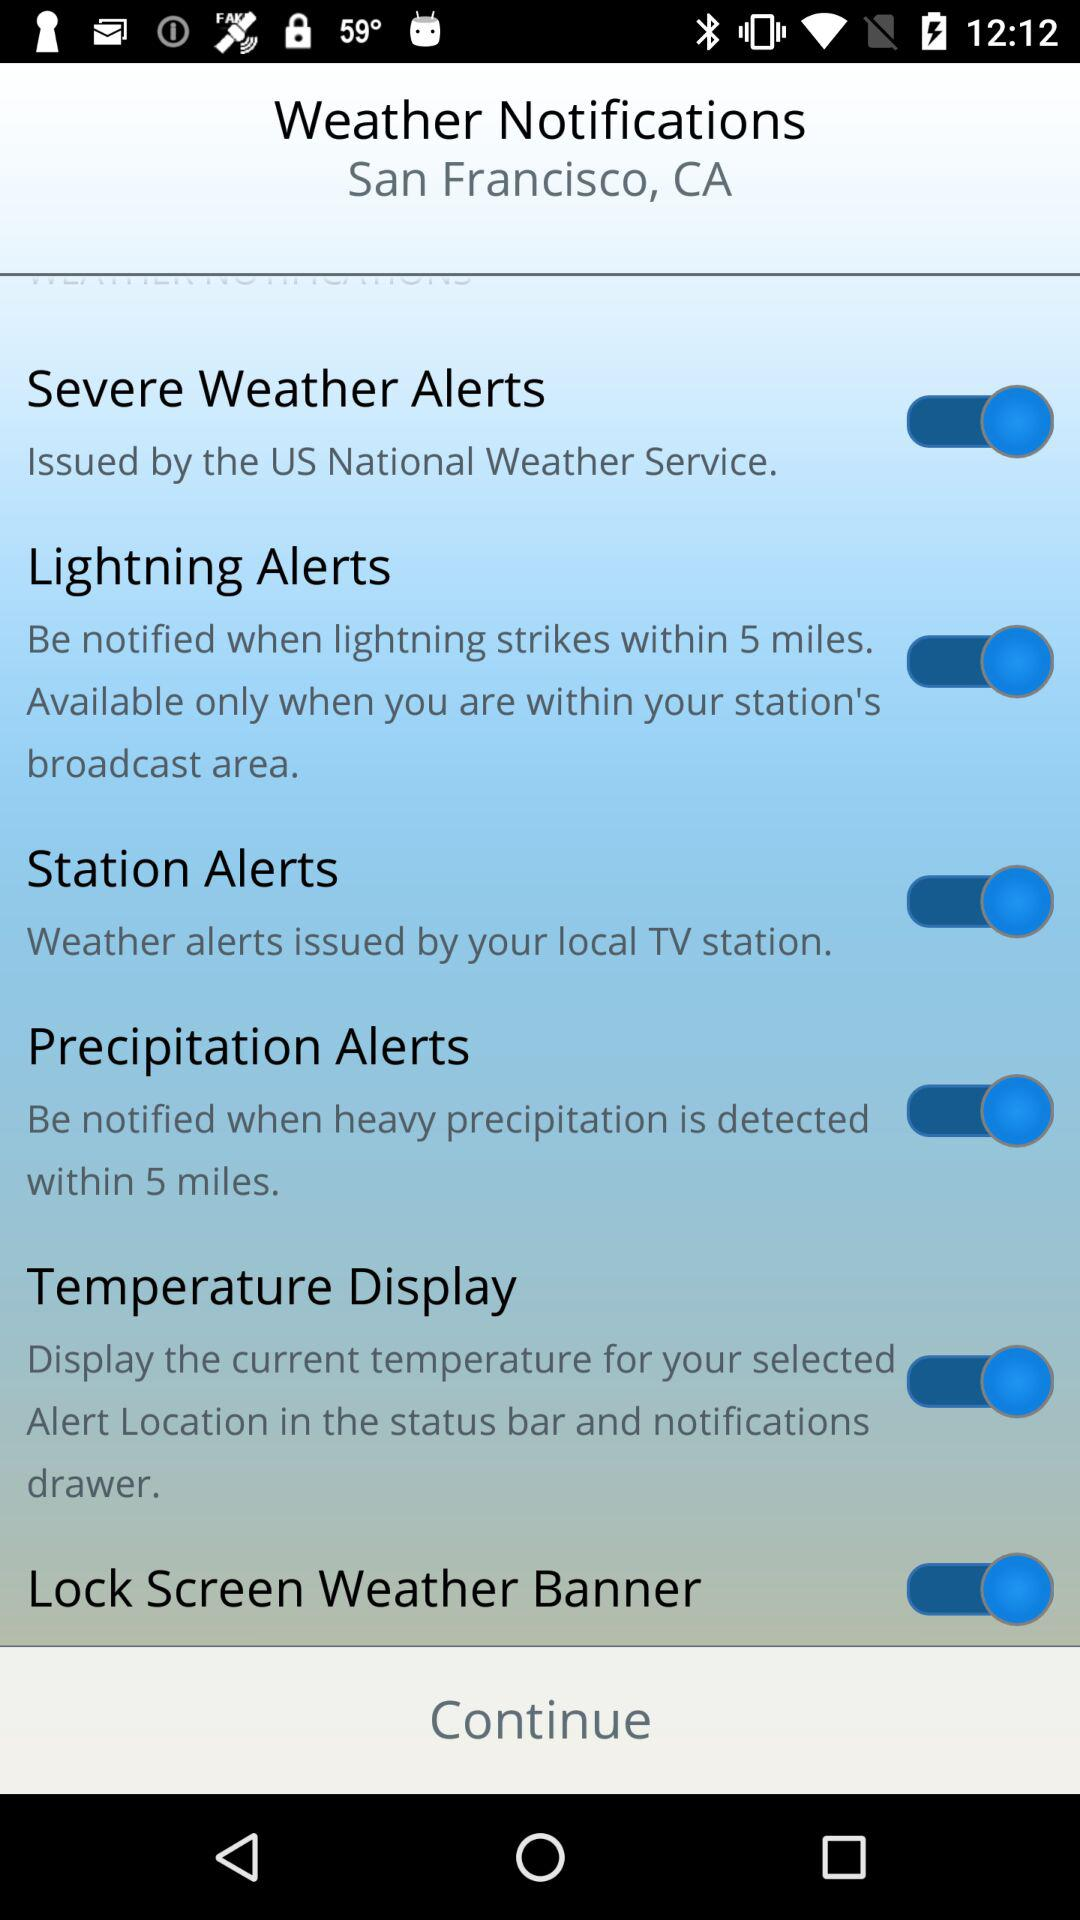What are the weather notifications? The weather notifications are "Severe Weather Alerts", "Lightning Alerts", "Station Alerts", "Precipitation Alerts", "Temperature Display" and "Lock Screen Weather Banner". 